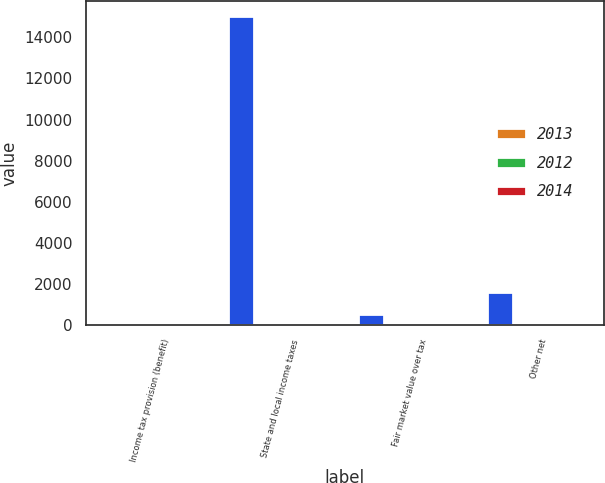<chart> <loc_0><loc_0><loc_500><loc_500><stacked_bar_chart><ecel><fcel>Income tax provision (benefit)<fcel>State and local income taxes<fcel>Fair market value over tax<fcel>Other net<nl><fcel>nan<fcel>35<fcel>15017<fcel>547<fcel>1598<nl><fcel>2013<fcel>35<fcel>5<fcel>0.2<fcel>0.5<nl><fcel>2012<fcel>35<fcel>98.3<fcel>0<fcel>36.5<nl><fcel>2014<fcel>35<fcel>1.7<fcel>1.7<fcel>0.5<nl></chart> 